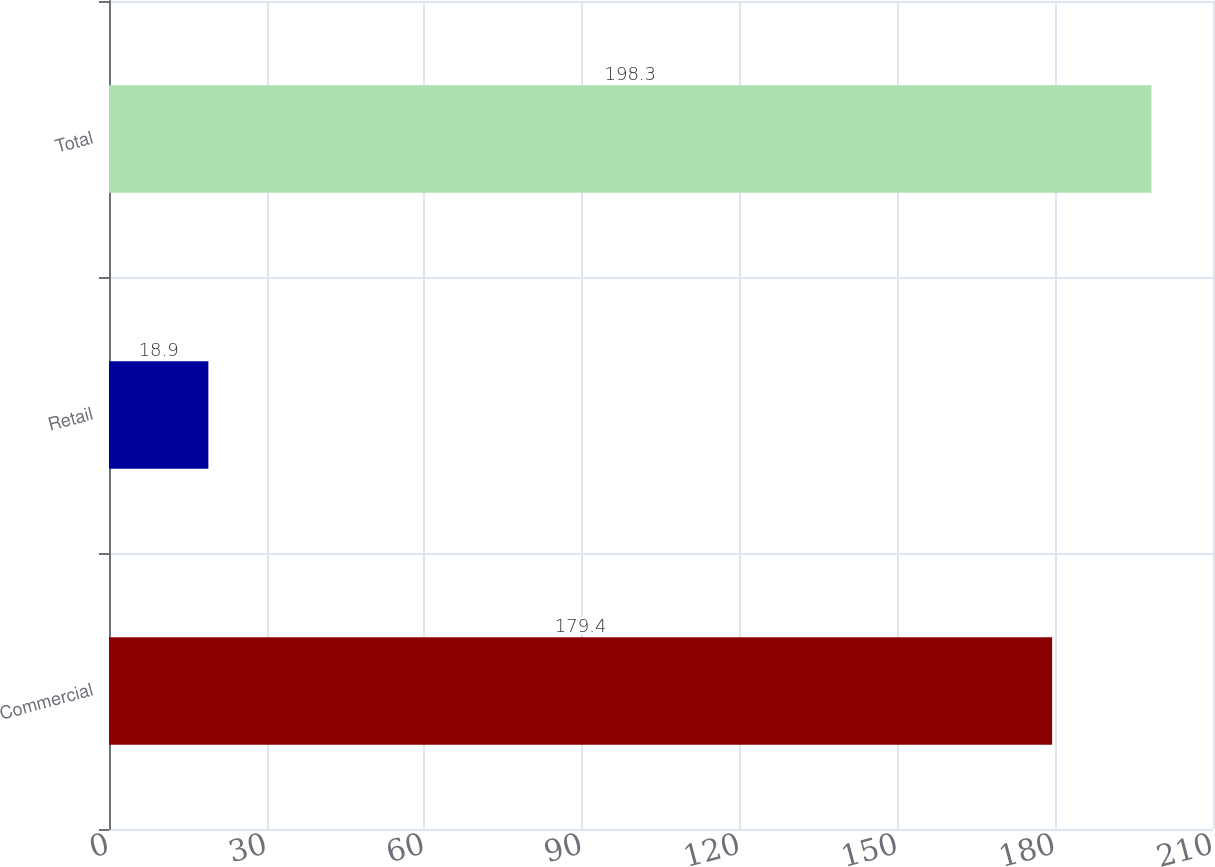Convert chart. <chart><loc_0><loc_0><loc_500><loc_500><bar_chart><fcel>Commercial<fcel>Retail<fcel>Total<nl><fcel>179.4<fcel>18.9<fcel>198.3<nl></chart> 